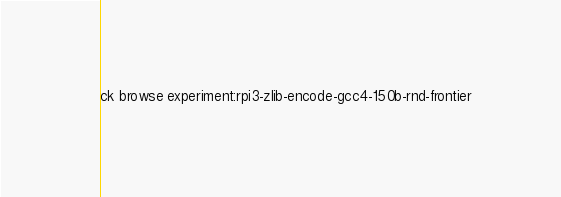<code> <loc_0><loc_0><loc_500><loc_500><_Bash_>ck browse experiment:rpi3-zlib-encode-gcc4-150b-rnd-frontier
</code> 